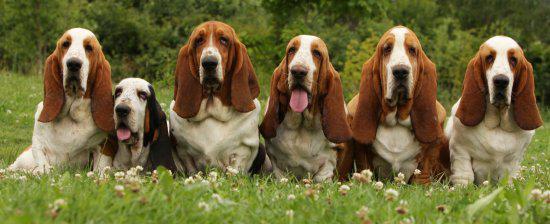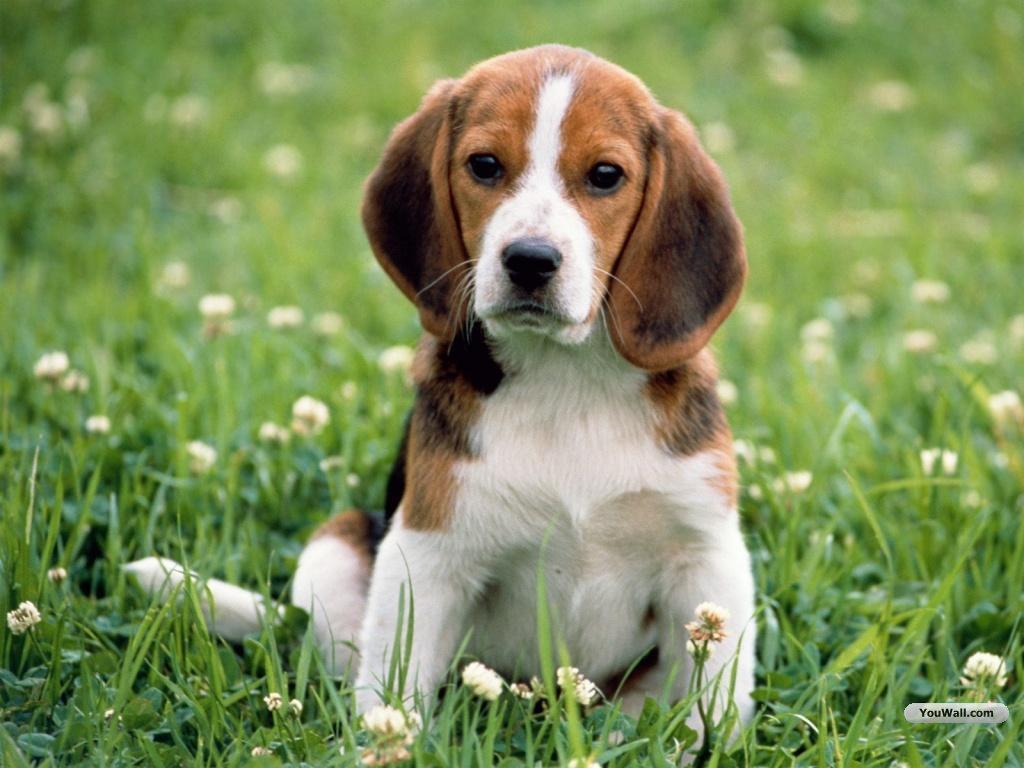The first image is the image on the left, the second image is the image on the right. Examine the images to the left and right. Is the description "Right and left images contain the same number of dogs." accurate? Answer yes or no. No. 